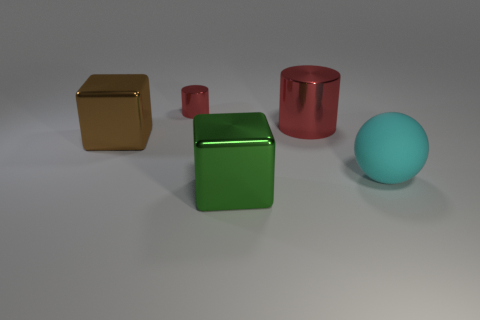Is there any other thing that is the same material as the big brown thing?
Ensure brevity in your answer.  Yes. How many large things have the same shape as the small red thing?
Ensure brevity in your answer.  1. There is a red cylinder that is made of the same material as the big red thing; what is its size?
Ensure brevity in your answer.  Small. There is a red cylinder that is right of the cube in front of the big brown metallic block; are there any shiny things in front of it?
Keep it short and to the point. Yes. Is the size of the metallic block in front of the rubber thing the same as the brown metallic cube?
Offer a very short reply. Yes. What number of green rubber spheres are the same size as the green cube?
Your answer should be very brief. 0. What is the size of the other metallic cylinder that is the same color as the large metallic cylinder?
Your response must be concise. Small. Is the color of the small cylinder the same as the large cylinder?
Offer a terse response. Yes. There is a tiny red shiny thing; what shape is it?
Make the answer very short. Cylinder. Are there any large metal cylinders that have the same color as the tiny metal object?
Provide a short and direct response. Yes. 